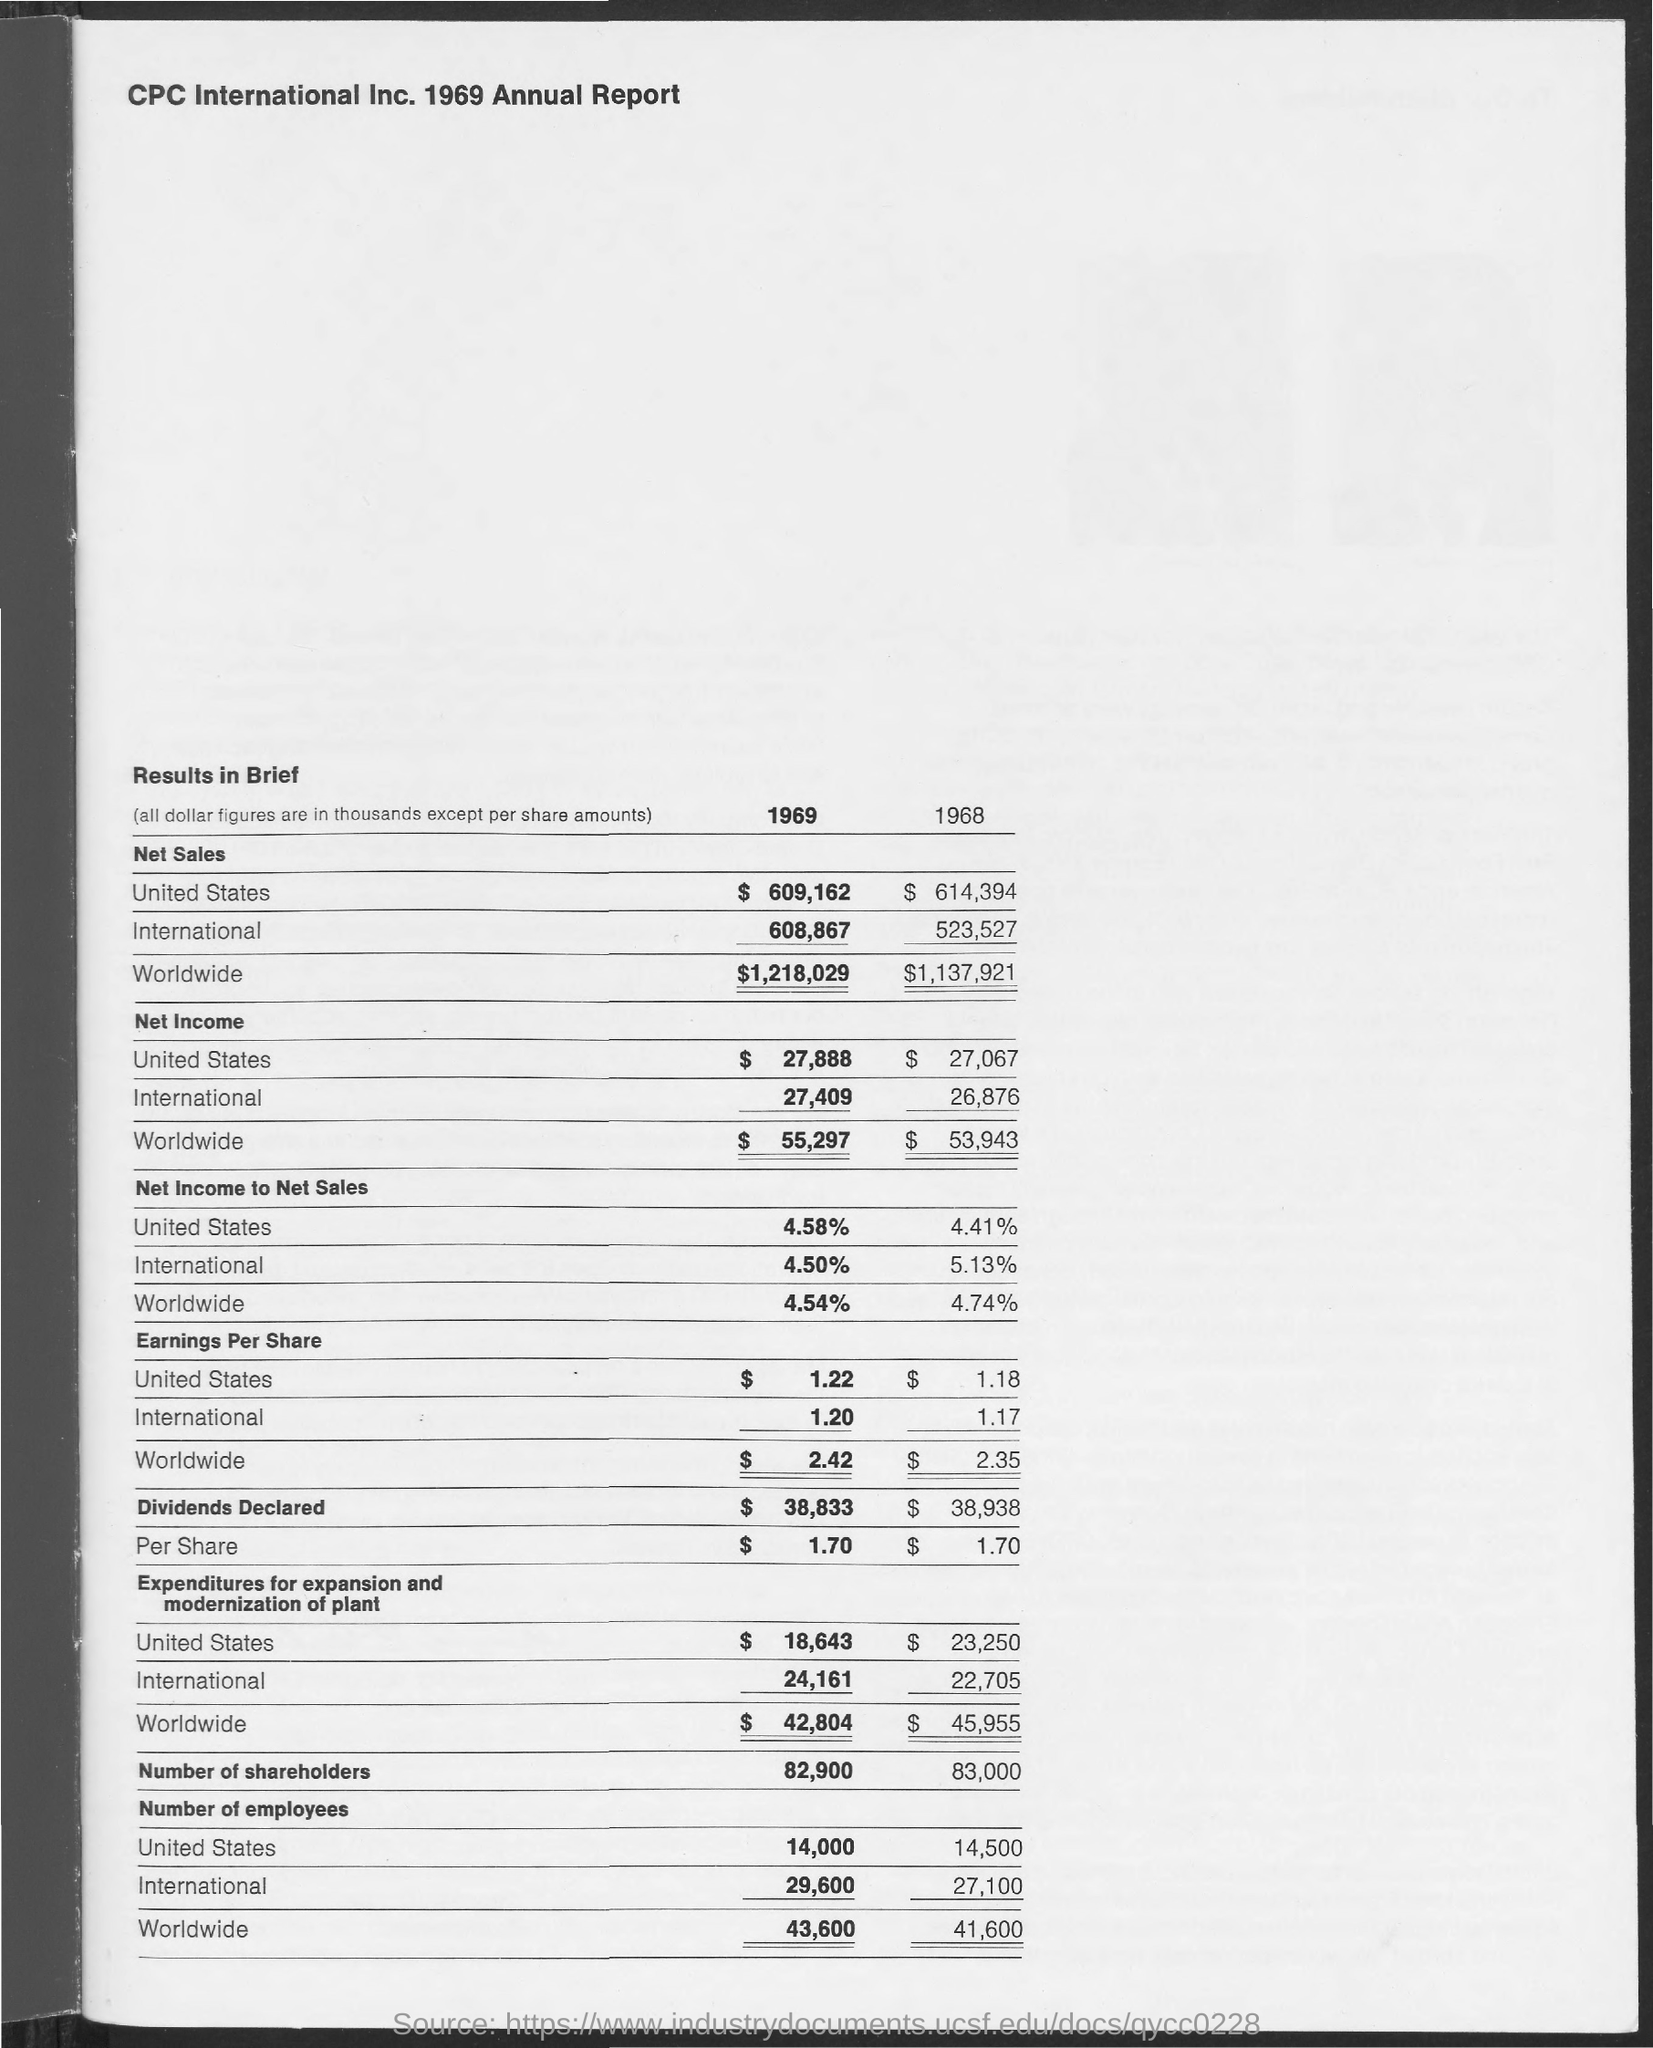Identify some key points in this picture. The worldwide net income of 1969 was 55,297. The international earnings per share in 1969 was 1 dollar. In 1969, the declared dividends were $38,833. CPC International Inc. 1969 Annual Report is the title of the document. 